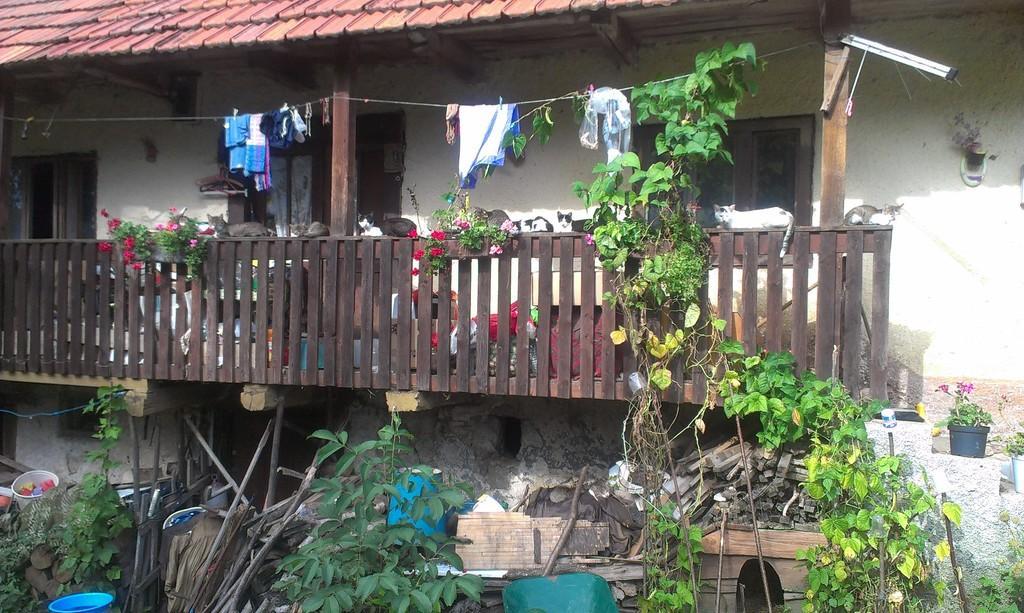How would you summarize this image in a sentence or two? In this image, we can see a roof house. There is a balcony in the middle of the image. There are some plants at the bottom of the image. There are clothes at the top of the image. 